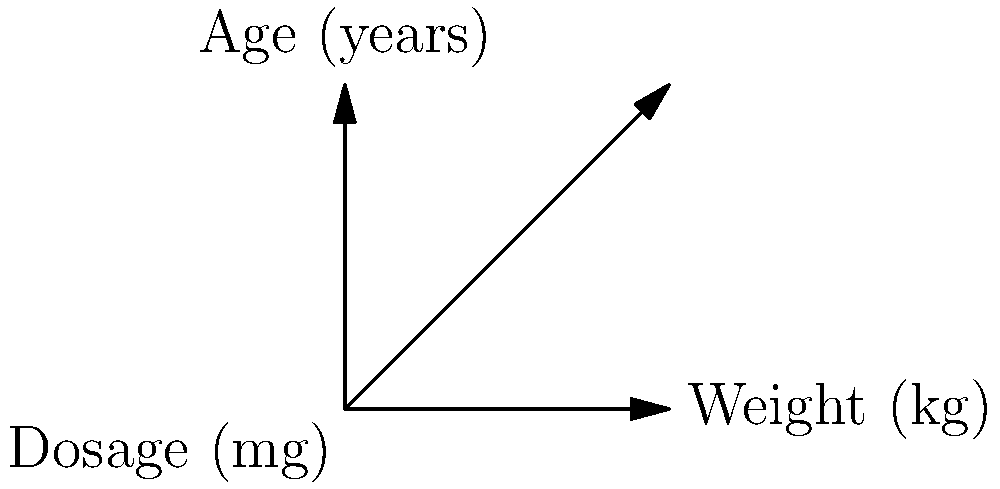Based on the 3D vector graph showing the relationship between patient weight, age, and dosages for drugs A and B, calculate the dosage vector for a combination medication for a patient weighing 65 kg and aged 35 years. Assume linear interpolation between the given data points. To solve this problem, we'll follow these steps:

1. Identify the nearest data points:
   - Lower bound: 60 kg, 30 years
   - Upper bound: 70 kg, 40 years

2. Calculate the interpolation factors:
   - Weight factor: $f_w = \frac{65 - 60}{70 - 60} = 0.5$
   - Age factor: $f_a = \frac{35 - 30}{40 - 30} = 0.5$

3. Interpolate dosages for Drug A:
   - Lower bound: 120 mg
   - Upper bound: 140 mg
   - Interpolated dosage: $120 + (140 - 120) \times 0.5 = 130$ mg

4. Interpolate dosages for Drug B:
   - Lower bound: 60 mg
   - Upper bound: 70 mg
   - Interpolated dosage: $60 + (70 - 60) \times 0.5 = 65$ mg

5. Combine the dosages into a vector:
   Dosage vector = $(130, 65)$

Therefore, the dosage vector for the combination medication is $(130, 65)$, where the first component represents the dosage for Drug A and the second component represents the dosage for Drug B.
Answer: $(130, 65)$ 